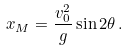Convert formula to latex. <formula><loc_0><loc_0><loc_500><loc_500>x _ { M } = \frac { v _ { 0 } ^ { 2 } } { g } \sin 2 \theta \, .</formula> 